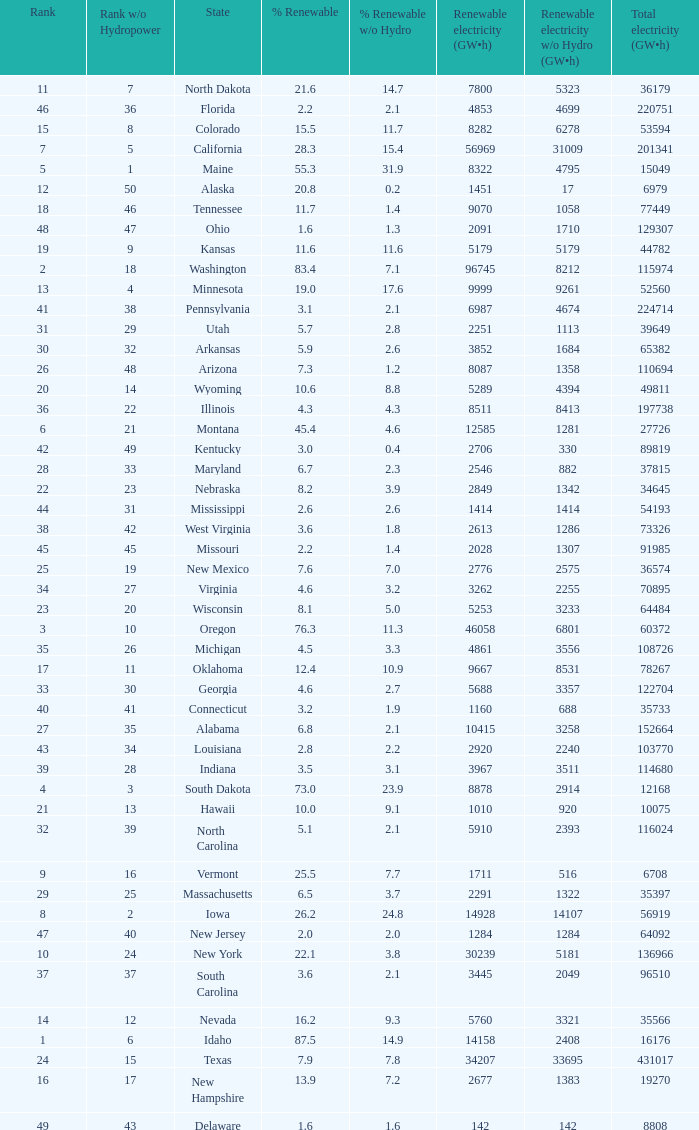What is the percentage of renewable electricity without hydrogen power in the state of South Dakota? 23.9. 